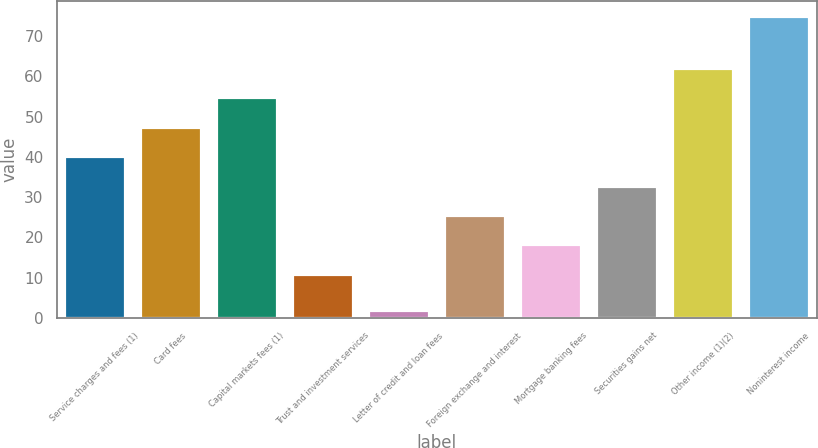Convert chart to OTSL. <chart><loc_0><loc_0><loc_500><loc_500><bar_chart><fcel>Service charges and fees (1)<fcel>Card fees<fcel>Capital markets fees (1)<fcel>Trust and investment services<fcel>Letter of credit and loan fees<fcel>Foreign exchange and interest<fcel>Mortgage banking fees<fcel>Securities gains net<fcel>Other income (1)(2)<fcel>Noninterest income<nl><fcel>40.2<fcel>47.5<fcel>54.8<fcel>11<fcel>2<fcel>25.6<fcel>18.3<fcel>32.9<fcel>62.1<fcel>75<nl></chart> 